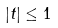<formula> <loc_0><loc_0><loc_500><loc_500>| t | \leq 1</formula> 